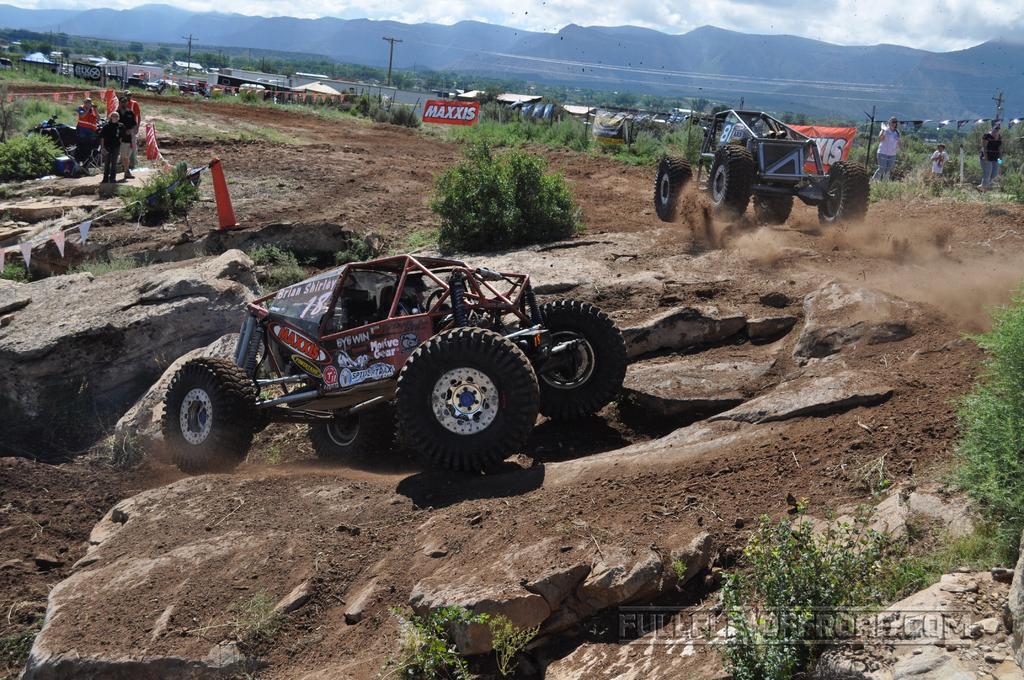How would you summarize this image in a sentence or two? In this picture we can see vehicles and people on the ground and in the background we can see sheds, trees, poles, banners, mountains and the sky. 